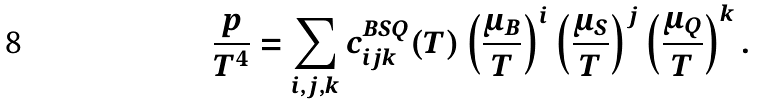<formula> <loc_0><loc_0><loc_500><loc_500>\frac { p } { T ^ { 4 } } = \sum _ { i , j , k } c ^ { B S Q } _ { i j k } ( T ) \left ( \frac { \mu _ { B } } { T } \right ) ^ { i } \left ( \frac { \mu _ { S } } { T } \right ) ^ { j } \left ( \frac { \mu _ { Q } } { T } \right ) ^ { k } .</formula> 